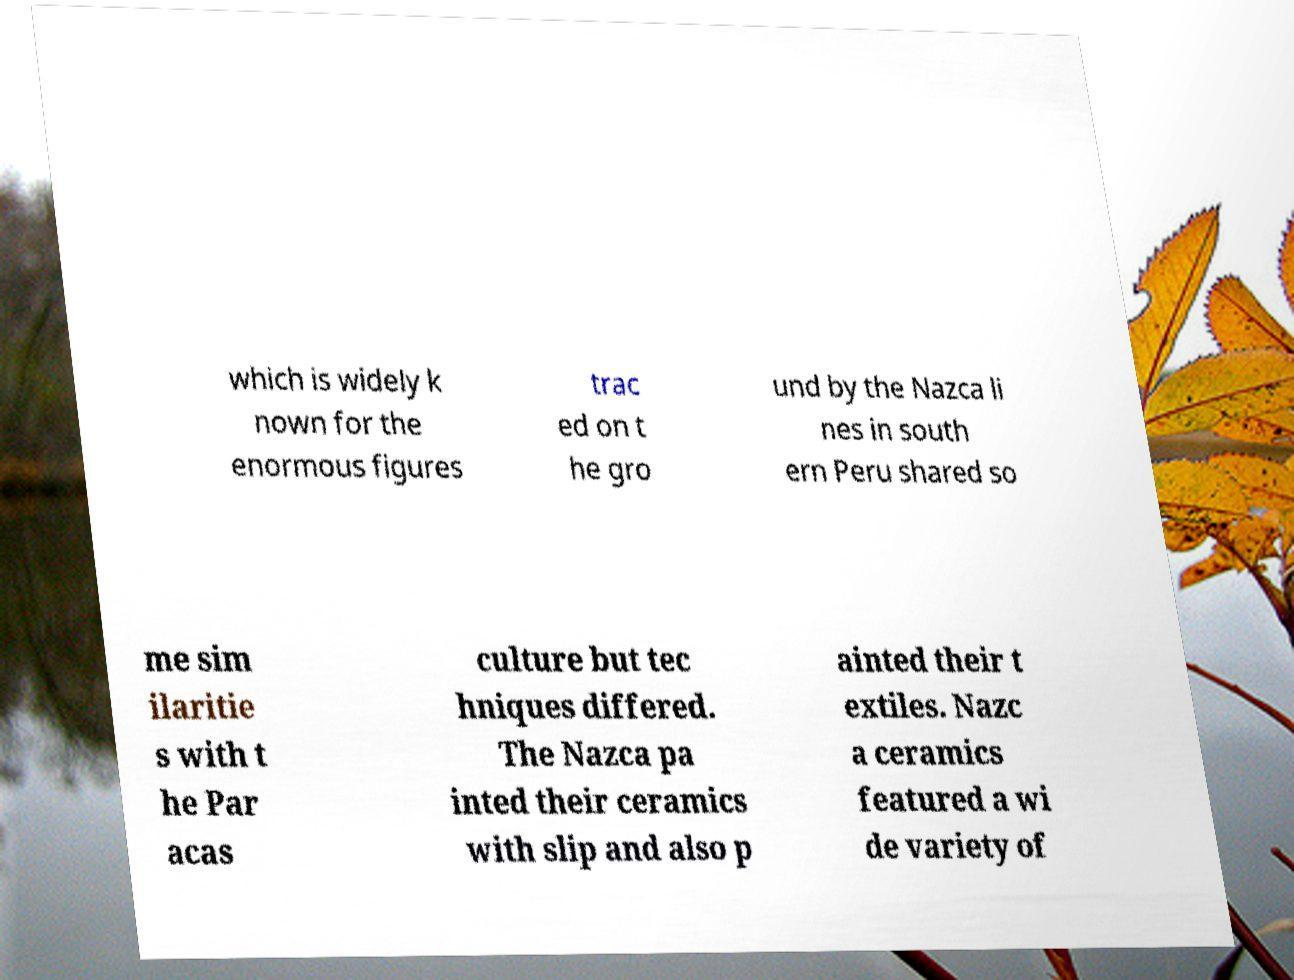Can you read and provide the text displayed in the image?This photo seems to have some interesting text. Can you extract and type it out for me? which is widely k nown for the enormous figures trac ed on t he gro und by the Nazca li nes in south ern Peru shared so me sim ilaritie s with t he Par acas culture but tec hniques differed. The Nazca pa inted their ceramics with slip and also p ainted their t extiles. Nazc a ceramics featured a wi de variety of 